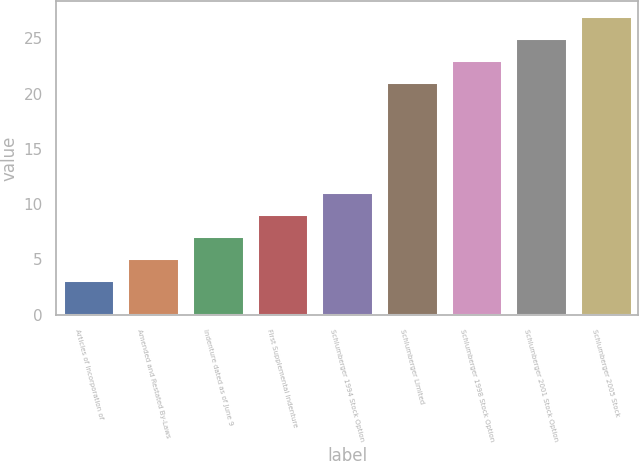Convert chart to OTSL. <chart><loc_0><loc_0><loc_500><loc_500><bar_chart><fcel>Articles of Incorporation of<fcel>Amended and Restated By-Laws<fcel>Indenture dated as of June 9<fcel>First Supplemental Indenture<fcel>Schlumberger 1994 Stock Option<fcel>Schlumberger Limited<fcel>Schlumberger 1998 Stock Option<fcel>Schlumberger 2001 Stock Option<fcel>Schlumberger 2005 Stock<nl><fcel>3.1<fcel>5.09<fcel>7.08<fcel>9.07<fcel>11.06<fcel>21.01<fcel>23<fcel>24.99<fcel>26.98<nl></chart> 